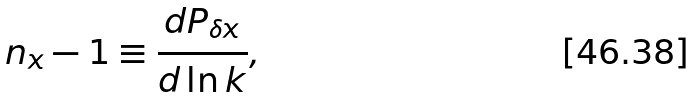Convert formula to latex. <formula><loc_0><loc_0><loc_500><loc_500>n _ { x } - 1 \equiv \frac { d P _ { \delta x } } { d \ln k } ,</formula> 